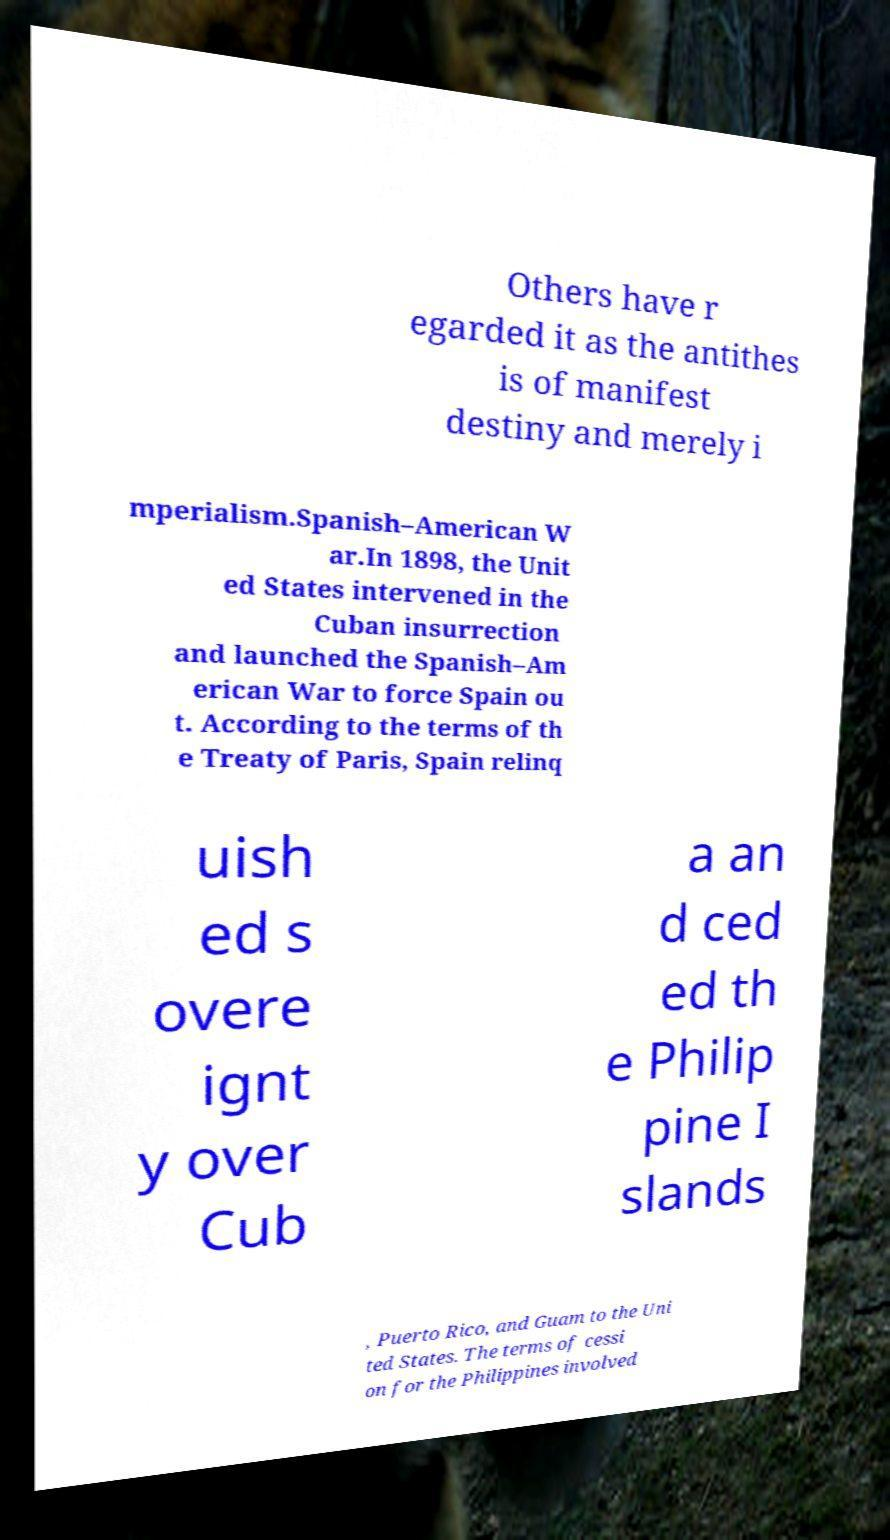For documentation purposes, I need the text within this image transcribed. Could you provide that? Others have r egarded it as the antithes is of manifest destiny and merely i mperialism.Spanish–American W ar.In 1898, the Unit ed States intervened in the Cuban insurrection and launched the Spanish–Am erican War to force Spain ou t. According to the terms of th e Treaty of Paris, Spain relinq uish ed s overe ignt y over Cub a an d ced ed th e Philip pine I slands , Puerto Rico, and Guam to the Uni ted States. The terms of cessi on for the Philippines involved 